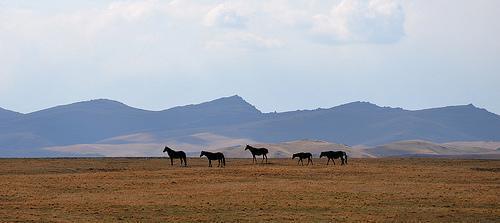How many horses are there?
Give a very brief answer. 5. 